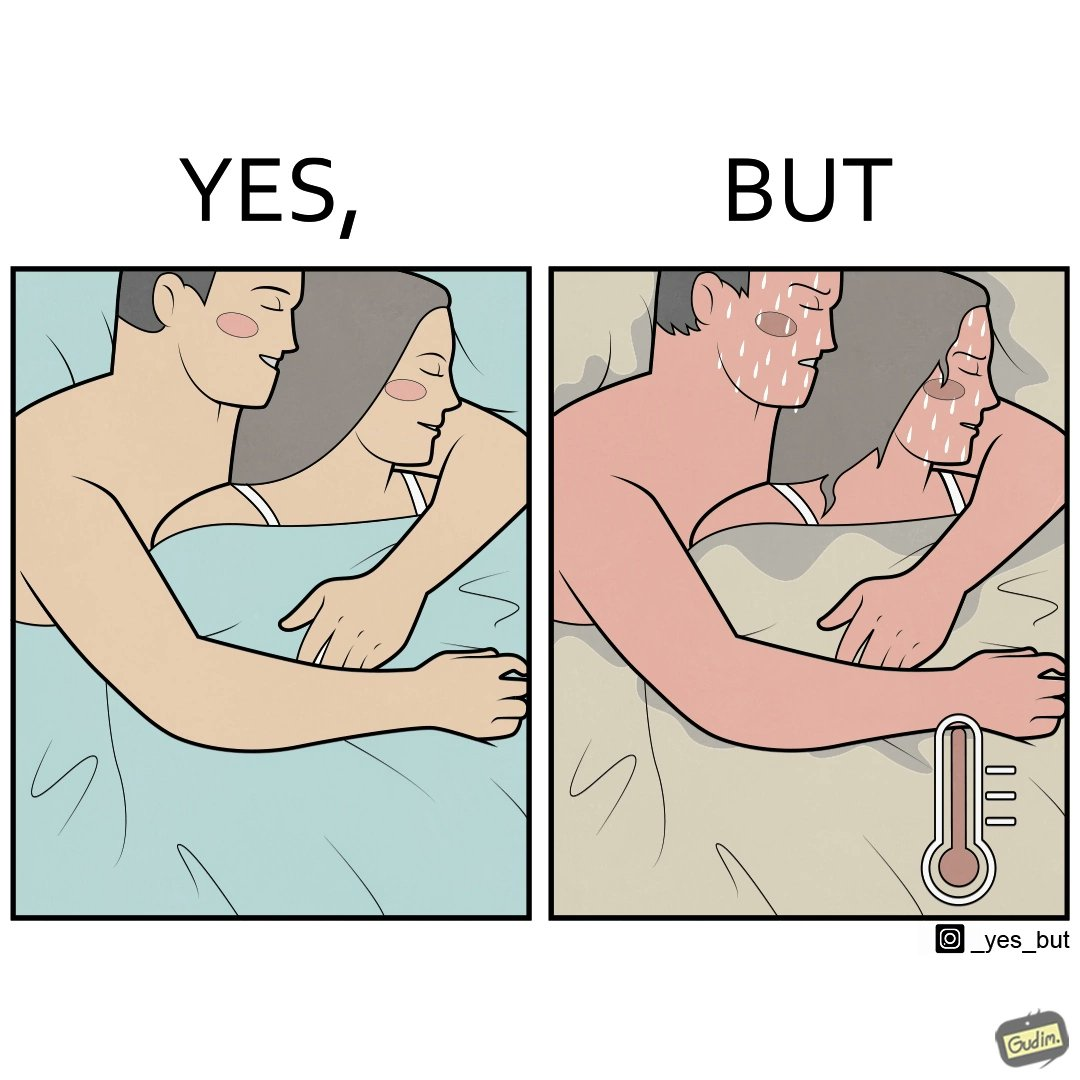Describe the contrast between the left and right parts of this image. In the left part of the image: a couple cuddling together in a blanket In the right part of the image: a couple feeling sweaty while cuddling together in a blanket 